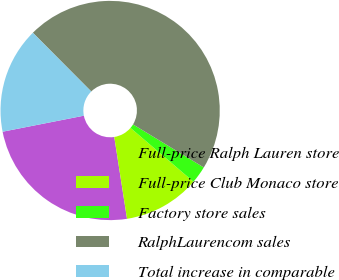<chart> <loc_0><loc_0><loc_500><loc_500><pie_chart><fcel>Full-price Ralph Lauren store<fcel>Full-price Club Monaco store<fcel>Factory store sales<fcel>RalphLaurencom sales<fcel>Total increase in comparable<nl><fcel>24.36%<fcel>11.28%<fcel>2.56%<fcel>46.15%<fcel>15.64%<nl></chart> 